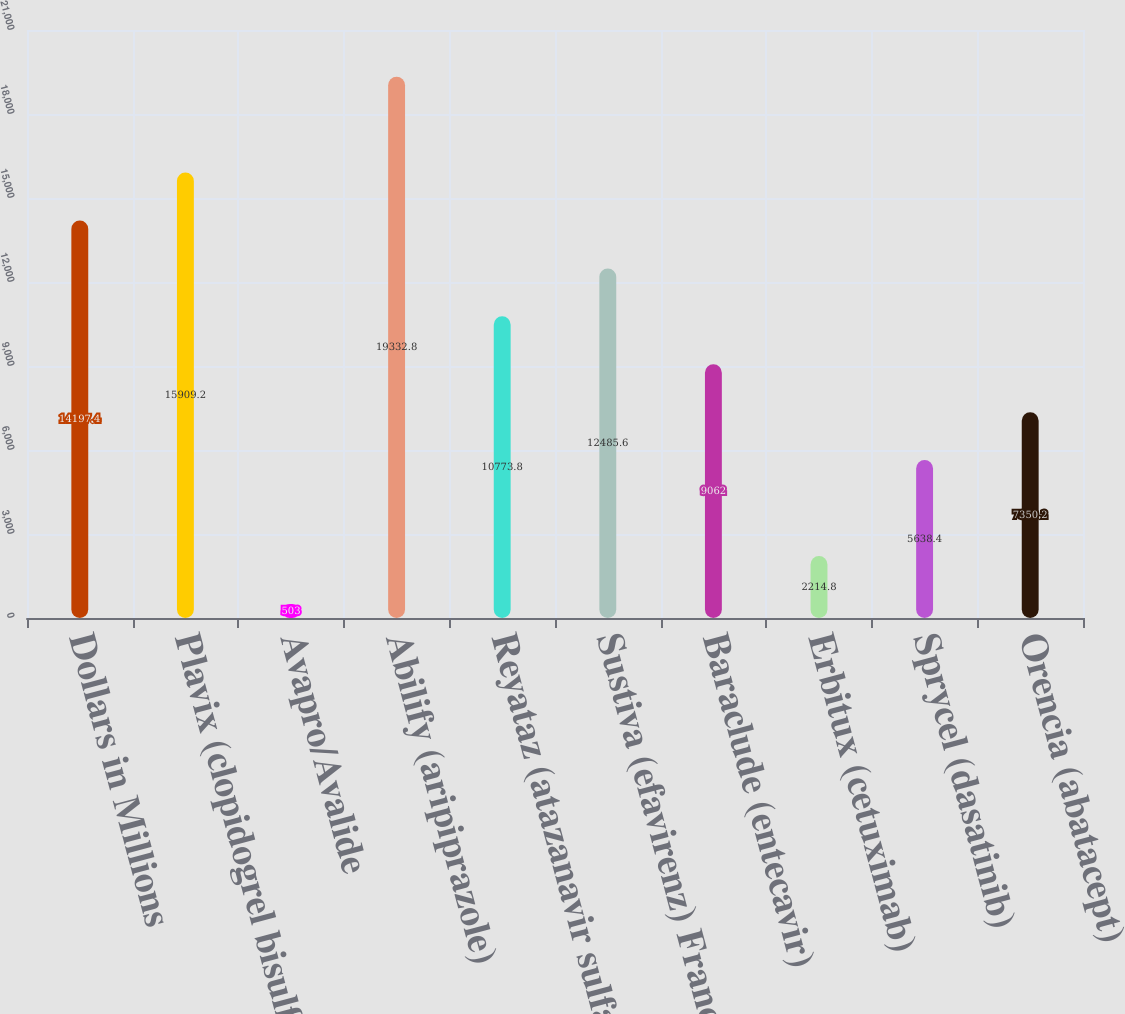Convert chart to OTSL. <chart><loc_0><loc_0><loc_500><loc_500><bar_chart><fcel>Dollars in Millions<fcel>Plavix (clopidogrel bisulfate)<fcel>Avapro/Avalide<fcel>Abilify (aripiprazole)<fcel>Reyataz (atazanavir sulfate)<fcel>Sustiva (efavirenz) Franchise<fcel>Baraclude (entecavir)<fcel>Erbitux (cetuximab)<fcel>Sprycel (dasatinib)<fcel>Orencia (abatacept)<nl><fcel>14197.4<fcel>15909.2<fcel>503<fcel>19332.8<fcel>10773.8<fcel>12485.6<fcel>9062<fcel>2214.8<fcel>5638.4<fcel>7350.2<nl></chart> 